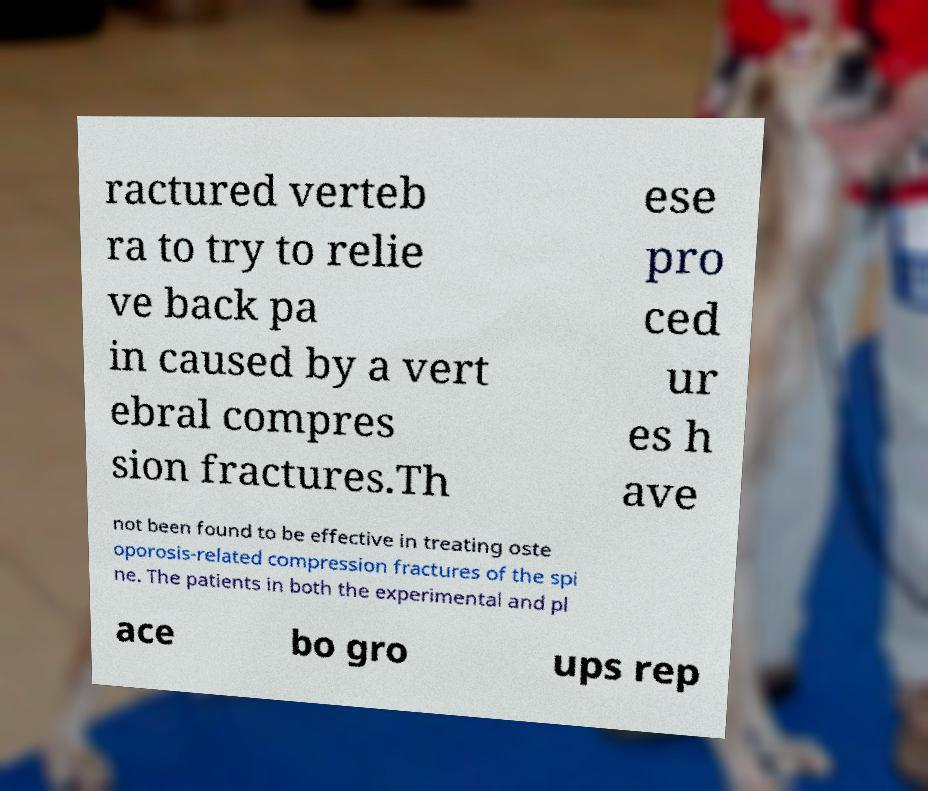Could you extract and type out the text from this image? ractured verteb ra to try to relie ve back pa in caused by a vert ebral compres sion fractures.Th ese pro ced ur es h ave not been found to be effective in treating oste oporosis-related compression fractures of the spi ne. The patients in both the experimental and pl ace bo gro ups rep 